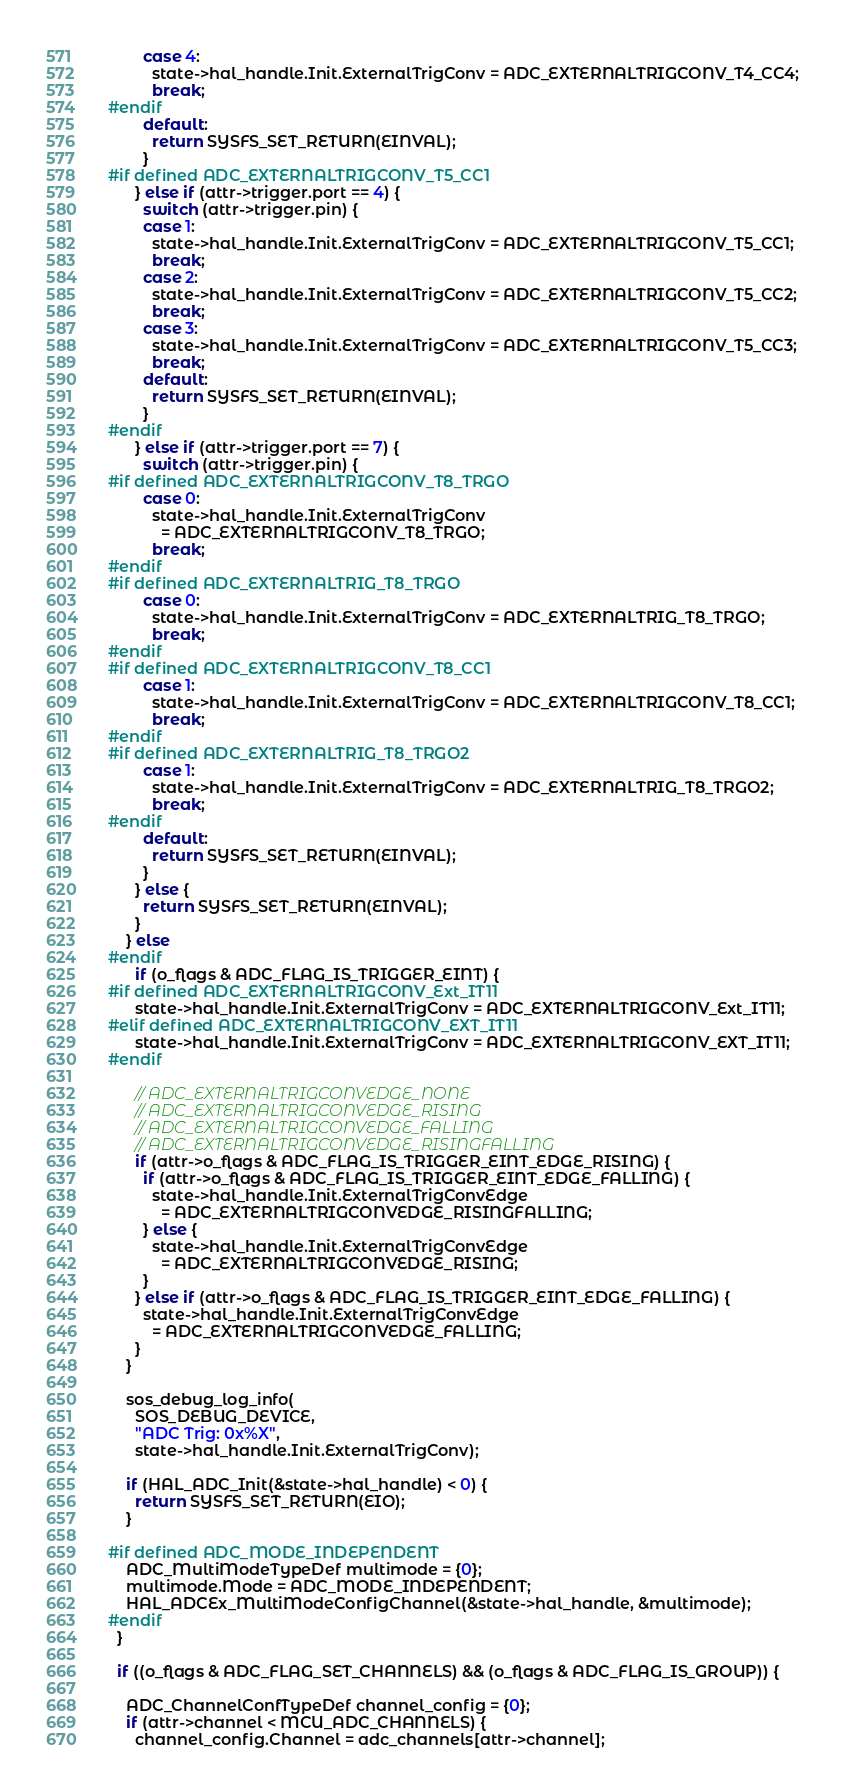Convert code to text. <code><loc_0><loc_0><loc_500><loc_500><_C_>        case 4:
          state->hal_handle.Init.ExternalTrigConv = ADC_EXTERNALTRIGCONV_T4_CC4;
          break;
#endif
        default:
          return SYSFS_SET_RETURN(EINVAL);
        }
#if defined ADC_EXTERNALTRIGCONV_T5_CC1
      } else if (attr->trigger.port == 4) {
        switch (attr->trigger.pin) {
        case 1:
          state->hal_handle.Init.ExternalTrigConv = ADC_EXTERNALTRIGCONV_T5_CC1;
          break;
        case 2:
          state->hal_handle.Init.ExternalTrigConv = ADC_EXTERNALTRIGCONV_T5_CC2;
          break;
        case 3:
          state->hal_handle.Init.ExternalTrigConv = ADC_EXTERNALTRIGCONV_T5_CC3;
          break;
        default:
          return SYSFS_SET_RETURN(EINVAL);
        }
#endif
      } else if (attr->trigger.port == 7) {
        switch (attr->trigger.pin) {
#if defined ADC_EXTERNALTRIGCONV_T8_TRGO
        case 0:
          state->hal_handle.Init.ExternalTrigConv
            = ADC_EXTERNALTRIGCONV_T8_TRGO;
          break;
#endif
#if defined ADC_EXTERNALTRIG_T8_TRGO
        case 0:
          state->hal_handle.Init.ExternalTrigConv = ADC_EXTERNALTRIG_T8_TRGO;
          break;
#endif
#if defined ADC_EXTERNALTRIGCONV_T8_CC1
        case 1:
          state->hal_handle.Init.ExternalTrigConv = ADC_EXTERNALTRIGCONV_T8_CC1;
          break;
#endif
#if defined ADC_EXTERNALTRIG_T8_TRGO2
        case 1:
          state->hal_handle.Init.ExternalTrigConv = ADC_EXTERNALTRIG_T8_TRGO2;
          break;
#endif
        default:
          return SYSFS_SET_RETURN(EINVAL);
        }
      } else {
        return SYSFS_SET_RETURN(EINVAL);
      }
    } else
#endif
      if (o_flags & ADC_FLAG_IS_TRIGGER_EINT) {
#if defined ADC_EXTERNALTRIGCONV_Ext_IT11
      state->hal_handle.Init.ExternalTrigConv = ADC_EXTERNALTRIGCONV_Ext_IT11;
#elif defined ADC_EXTERNALTRIGCONV_EXT_IT11
      state->hal_handle.Init.ExternalTrigConv = ADC_EXTERNALTRIGCONV_EXT_IT11;
#endif

      // ADC_EXTERNALTRIGCONVEDGE_NONE
      // ADC_EXTERNALTRIGCONVEDGE_RISING
      // ADC_EXTERNALTRIGCONVEDGE_FALLING
      // ADC_EXTERNALTRIGCONVEDGE_RISINGFALLING
      if (attr->o_flags & ADC_FLAG_IS_TRIGGER_EINT_EDGE_RISING) {
        if (attr->o_flags & ADC_FLAG_IS_TRIGGER_EINT_EDGE_FALLING) {
          state->hal_handle.Init.ExternalTrigConvEdge
            = ADC_EXTERNALTRIGCONVEDGE_RISINGFALLING;
        } else {
          state->hal_handle.Init.ExternalTrigConvEdge
            = ADC_EXTERNALTRIGCONVEDGE_RISING;
        }
      } else if (attr->o_flags & ADC_FLAG_IS_TRIGGER_EINT_EDGE_FALLING) {
        state->hal_handle.Init.ExternalTrigConvEdge
          = ADC_EXTERNALTRIGCONVEDGE_FALLING;
      }
    }

    sos_debug_log_info(
      SOS_DEBUG_DEVICE,
      "ADC Trig: 0x%X",
      state->hal_handle.Init.ExternalTrigConv);

    if (HAL_ADC_Init(&state->hal_handle) < 0) {
      return SYSFS_SET_RETURN(EIO);
    }

#if defined ADC_MODE_INDEPENDENT
    ADC_MultiModeTypeDef multimode = {0};
    multimode.Mode = ADC_MODE_INDEPENDENT;
    HAL_ADCEx_MultiModeConfigChannel(&state->hal_handle, &multimode);
#endif
  }

  if ((o_flags & ADC_FLAG_SET_CHANNELS) && (o_flags & ADC_FLAG_IS_GROUP)) {

    ADC_ChannelConfTypeDef channel_config = {0};
    if (attr->channel < MCU_ADC_CHANNELS) {
      channel_config.Channel = adc_channels[attr->channel];</code> 